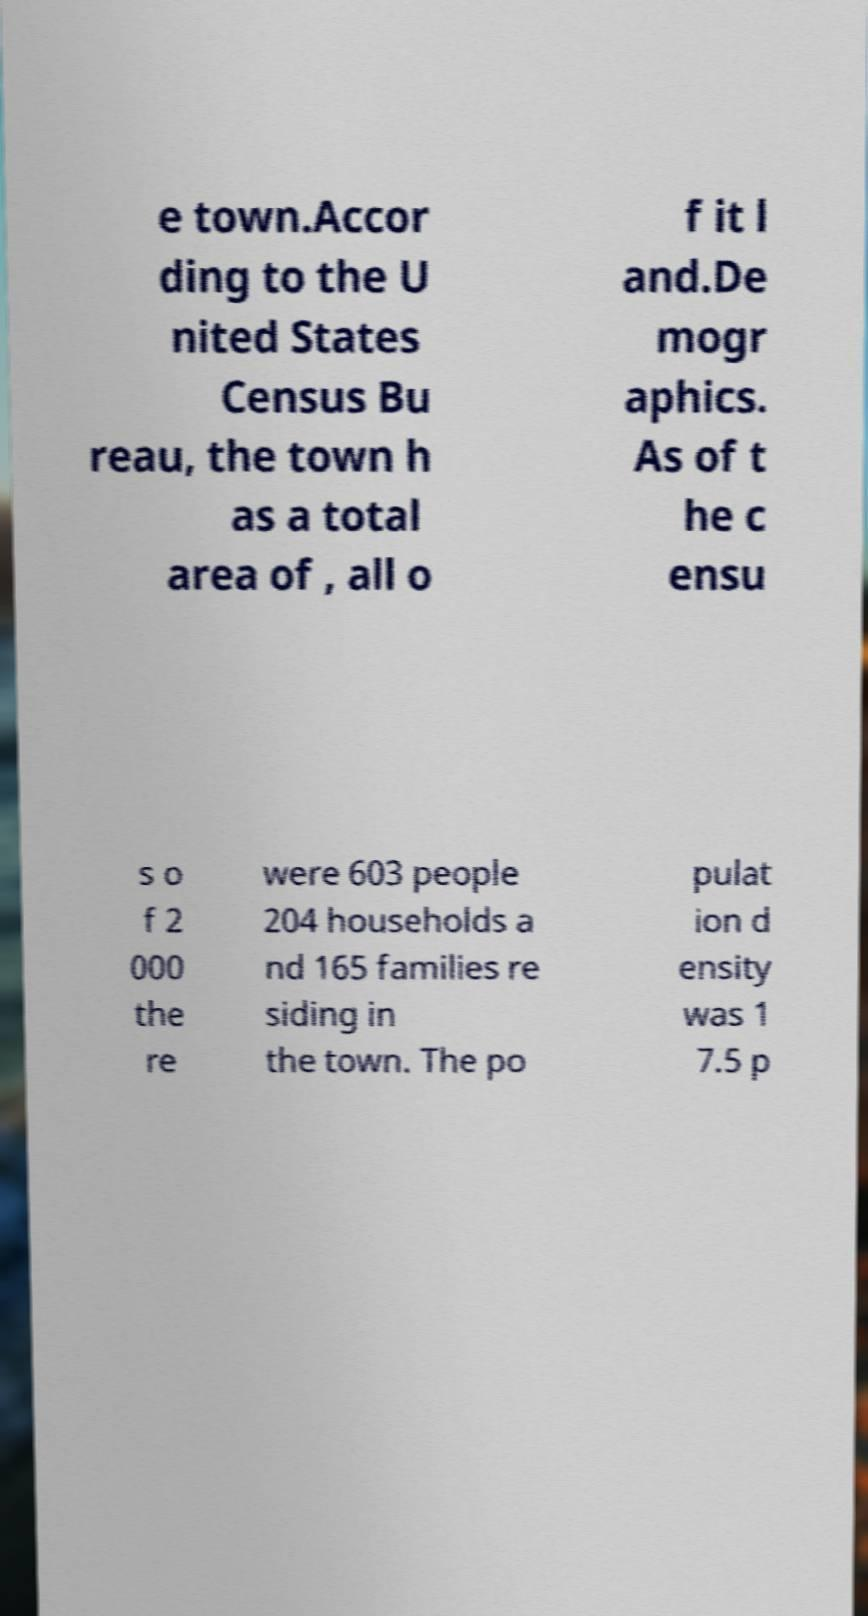Could you assist in decoding the text presented in this image and type it out clearly? e town.Accor ding to the U nited States Census Bu reau, the town h as a total area of , all o f it l and.De mogr aphics. As of t he c ensu s o f 2 000 the re were 603 people 204 households a nd 165 families re siding in the town. The po pulat ion d ensity was 1 7.5 p 